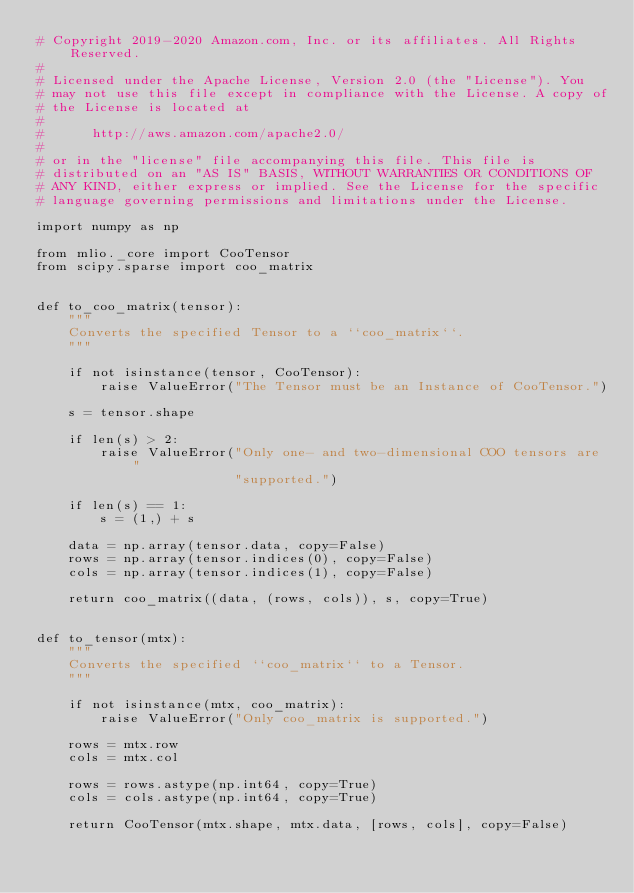Convert code to text. <code><loc_0><loc_0><loc_500><loc_500><_Python_># Copyright 2019-2020 Amazon.com, Inc. or its affiliates. All Rights Reserved.
#
# Licensed under the Apache License, Version 2.0 (the "License"). You
# may not use this file except in compliance with the License. A copy of
# the License is located at
#
#      http://aws.amazon.com/apache2.0/
#
# or in the "license" file accompanying this file. This file is
# distributed on an "AS IS" BASIS, WITHOUT WARRANTIES OR CONDITIONS OF
# ANY KIND, either express or implied. See the License for the specific
# language governing permissions and limitations under the License.

import numpy as np

from mlio._core import CooTensor
from scipy.sparse import coo_matrix


def to_coo_matrix(tensor):
    """
    Converts the specified Tensor to a ``coo_matrix``.
    """

    if not isinstance(tensor, CooTensor):
        raise ValueError("The Tensor must be an Instance of CooTensor.")

    s = tensor.shape

    if len(s) > 2:
        raise ValueError("Only one- and two-dimensional COO tensors are "
                         "supported.")

    if len(s) == 1:
        s = (1,) + s

    data = np.array(tensor.data, copy=False)
    rows = np.array(tensor.indices(0), copy=False)
    cols = np.array(tensor.indices(1), copy=False)

    return coo_matrix((data, (rows, cols)), s, copy=True)


def to_tensor(mtx):
    """
    Converts the specified ``coo_matrix`` to a Tensor.
    """

    if not isinstance(mtx, coo_matrix):
        raise ValueError("Only coo_matrix is supported.")

    rows = mtx.row
    cols = mtx.col

    rows = rows.astype(np.int64, copy=True)
    cols = cols.astype(np.int64, copy=True)

    return CooTensor(mtx.shape, mtx.data, [rows, cols], copy=False)
</code> 